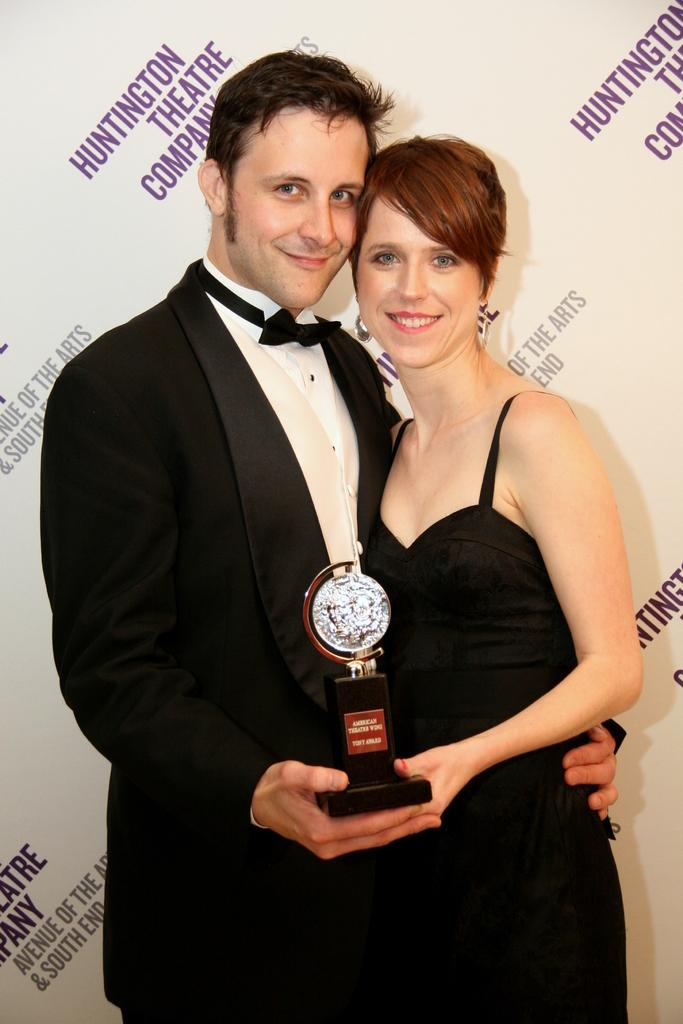Provide a one-sentence caption for the provided image. Man with Woman that are sharing an award together and getting their picture taken, Sponsored by the Huntington Theater Company. 